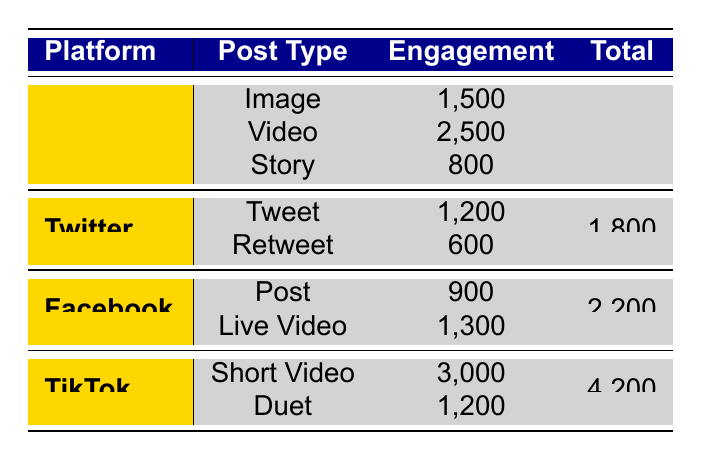What is the total engagement for Instagram posts? Adding the engagement values for all Instagram post types: 1500 (Image) + 2500 (Video) + 800 (Story) = 4800.
Answer: 4800 Which post type on Facebook has the highest engagement? By comparing the engagement values for Facebook posts, 900 (Post) and 1300 (Live Video), we see that Live Video has the highest engagement.
Answer: Live Video True or False: The total engagement for TikTok posts is less than Instagram posts. The total engagement for TikTok is 4200 (3000 + 1200) and for Instagram, it is 4800. Since 4200 is less than 4800, the statement is true.
Answer: True How much more engagement does TikTok’s Short Video have compared to Twitter’s combined engagement? The total engagement for Twitter is 1200 (Tweet) + 600 (Retweet) = 1800. The engagement for TikTok's Short Video is 3000. Subtracting these gives 3000 - 1800 = 1200.
Answer: 1200 What is the average engagement for posts across all platforms? First, calculate the total engagement: 4800 (Instagram) + 1800 (Twitter) + 2200 (Facebook) + 4200 (TikTok) = 13000. There are 8 post types, so the average engagement is 13000 / 8 = 1625.
Answer: 1625 Which platform has the lowest total engagement and what is that value? Comparing total engagements, Instagram has 4800, Twitter has 1800, Facebook has 2200, and TikTok has 4200. The lowest is Twitter at 1800.
Answer: Twitter, 1800 What is the combined engagement of all image and video posts? The relevant values are 1500 (Instagram Image) + 2500 (Instagram Video) + 900 (Facebook Post) + 3000 (TikTok Short Video) = 7900.
Answer: 7900 True or False: The engagement for a Video post on Instagram is greater than a Retweet on Twitter. The engagement for the Instagram Video is 2500, while the Retweet engagement is 600. Since 2500 is greater than 600, the statement is true.
Answer: True 